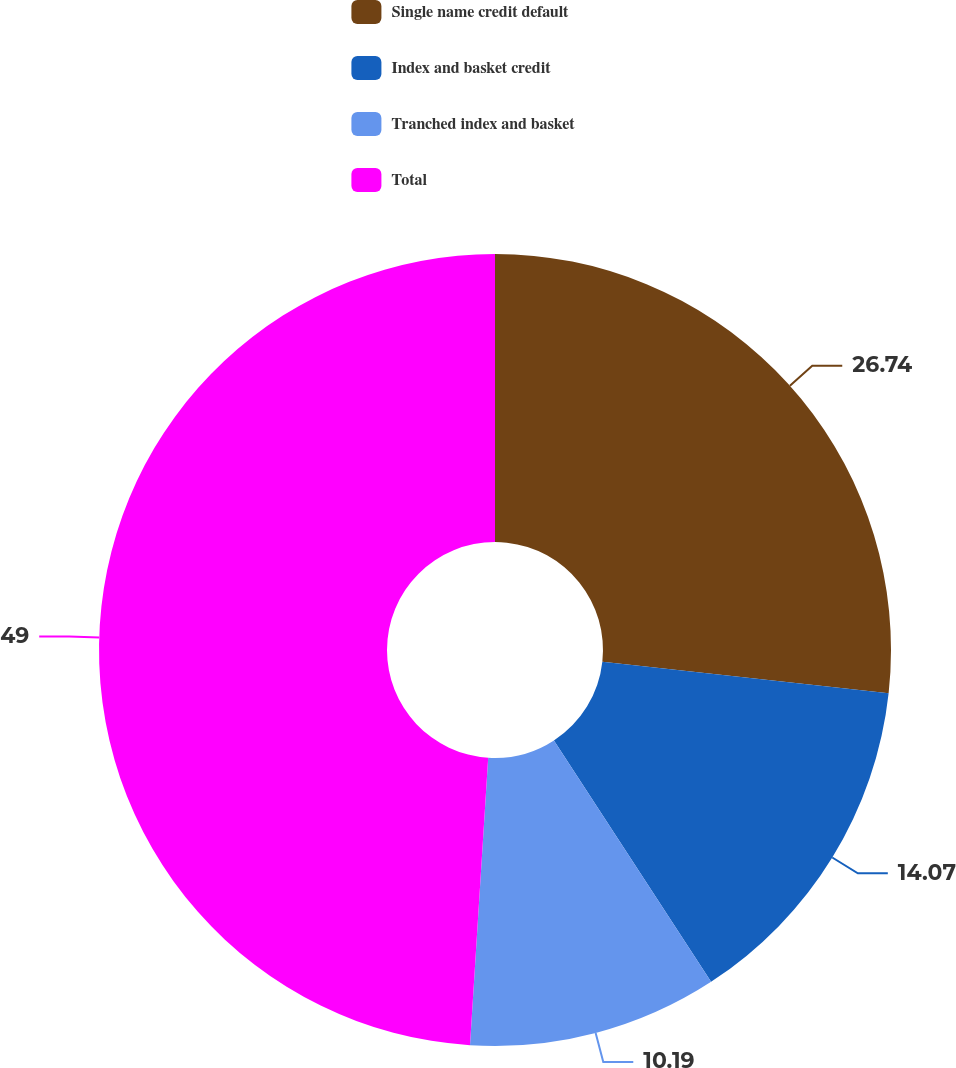Convert chart to OTSL. <chart><loc_0><loc_0><loc_500><loc_500><pie_chart><fcel>Single name credit default<fcel>Index and basket credit<fcel>Tranched index and basket<fcel>Total<nl><fcel>26.74%<fcel>14.07%<fcel>10.19%<fcel>48.99%<nl></chart> 